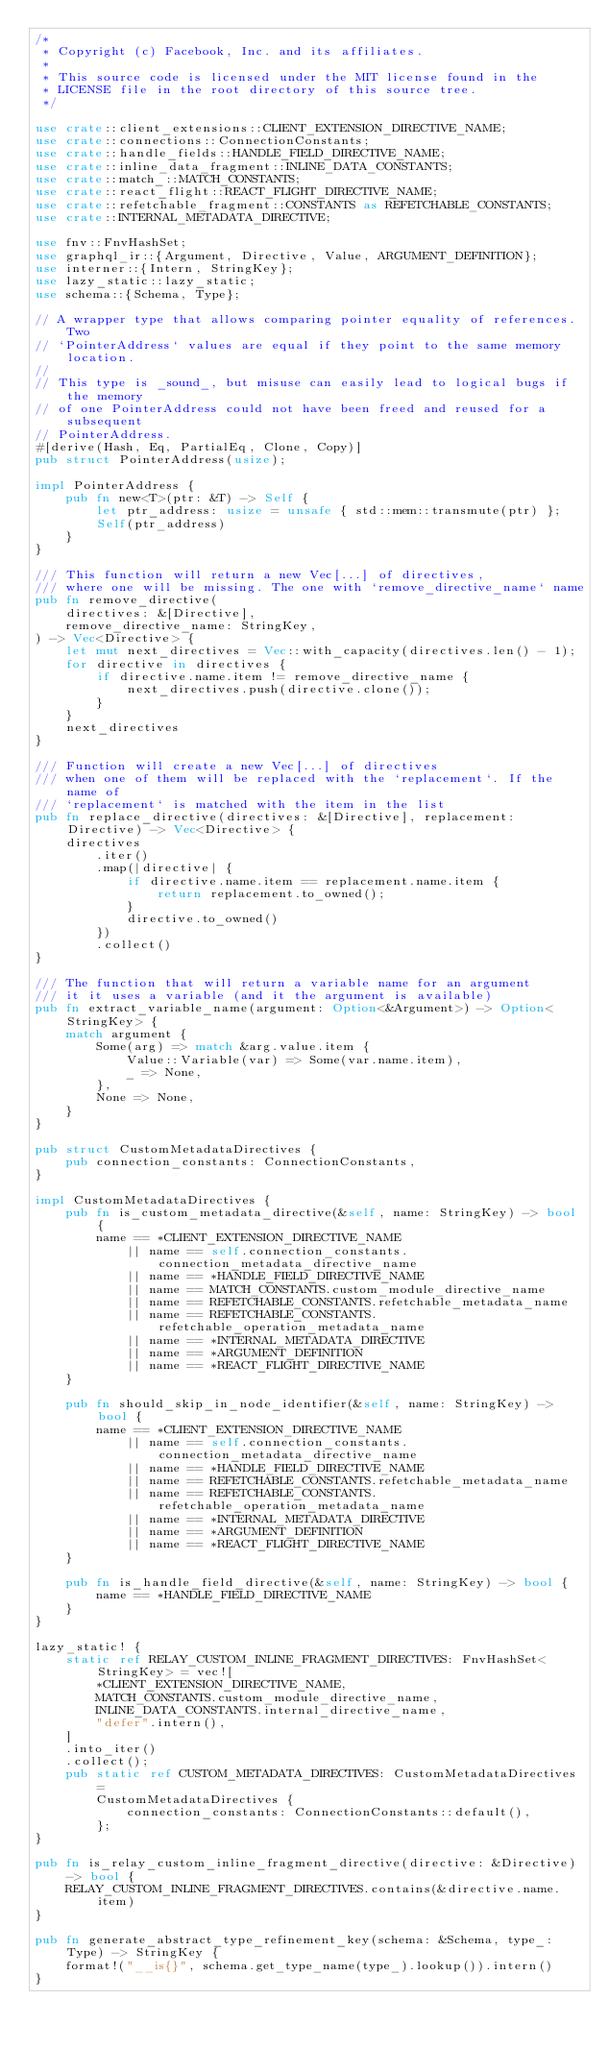<code> <loc_0><loc_0><loc_500><loc_500><_Rust_>/*
 * Copyright (c) Facebook, Inc. and its affiliates.
 *
 * This source code is licensed under the MIT license found in the
 * LICENSE file in the root directory of this source tree.
 */

use crate::client_extensions::CLIENT_EXTENSION_DIRECTIVE_NAME;
use crate::connections::ConnectionConstants;
use crate::handle_fields::HANDLE_FIELD_DIRECTIVE_NAME;
use crate::inline_data_fragment::INLINE_DATA_CONSTANTS;
use crate::match_::MATCH_CONSTANTS;
use crate::react_flight::REACT_FLIGHT_DIRECTIVE_NAME;
use crate::refetchable_fragment::CONSTANTS as REFETCHABLE_CONSTANTS;
use crate::INTERNAL_METADATA_DIRECTIVE;

use fnv::FnvHashSet;
use graphql_ir::{Argument, Directive, Value, ARGUMENT_DEFINITION};
use interner::{Intern, StringKey};
use lazy_static::lazy_static;
use schema::{Schema, Type};

// A wrapper type that allows comparing pointer equality of references. Two
// `PointerAddress` values are equal if they point to the same memory location.
//
// This type is _sound_, but misuse can easily lead to logical bugs if the memory
// of one PointerAddress could not have been freed and reused for a subsequent
// PointerAddress.
#[derive(Hash, Eq, PartialEq, Clone, Copy)]
pub struct PointerAddress(usize);

impl PointerAddress {
    pub fn new<T>(ptr: &T) -> Self {
        let ptr_address: usize = unsafe { std::mem::transmute(ptr) };
        Self(ptr_address)
    }
}

/// This function will return a new Vec[...] of directives,
/// where one will be missing. The one with `remove_directive_name` name
pub fn remove_directive(
    directives: &[Directive],
    remove_directive_name: StringKey,
) -> Vec<Directive> {
    let mut next_directives = Vec::with_capacity(directives.len() - 1);
    for directive in directives {
        if directive.name.item != remove_directive_name {
            next_directives.push(directive.clone());
        }
    }
    next_directives
}

/// Function will create a new Vec[...] of directives
/// when one of them will be replaced with the `replacement`. If the name of
/// `replacement` is matched with the item in the list
pub fn replace_directive(directives: &[Directive], replacement: Directive) -> Vec<Directive> {
    directives
        .iter()
        .map(|directive| {
            if directive.name.item == replacement.name.item {
                return replacement.to_owned();
            }
            directive.to_owned()
        })
        .collect()
}

/// The function that will return a variable name for an argument
/// it it uses a variable (and it the argument is available)
pub fn extract_variable_name(argument: Option<&Argument>) -> Option<StringKey> {
    match argument {
        Some(arg) => match &arg.value.item {
            Value::Variable(var) => Some(var.name.item),
            _ => None,
        },
        None => None,
    }
}

pub struct CustomMetadataDirectives {
    pub connection_constants: ConnectionConstants,
}

impl CustomMetadataDirectives {
    pub fn is_custom_metadata_directive(&self, name: StringKey) -> bool {
        name == *CLIENT_EXTENSION_DIRECTIVE_NAME
            || name == self.connection_constants.connection_metadata_directive_name
            || name == *HANDLE_FIELD_DIRECTIVE_NAME
            || name == MATCH_CONSTANTS.custom_module_directive_name
            || name == REFETCHABLE_CONSTANTS.refetchable_metadata_name
            || name == REFETCHABLE_CONSTANTS.refetchable_operation_metadata_name
            || name == *INTERNAL_METADATA_DIRECTIVE
            || name == *ARGUMENT_DEFINITION
            || name == *REACT_FLIGHT_DIRECTIVE_NAME
    }

    pub fn should_skip_in_node_identifier(&self, name: StringKey) -> bool {
        name == *CLIENT_EXTENSION_DIRECTIVE_NAME
            || name == self.connection_constants.connection_metadata_directive_name
            || name == *HANDLE_FIELD_DIRECTIVE_NAME
            || name == REFETCHABLE_CONSTANTS.refetchable_metadata_name
            || name == REFETCHABLE_CONSTANTS.refetchable_operation_metadata_name
            || name == *INTERNAL_METADATA_DIRECTIVE
            || name == *ARGUMENT_DEFINITION
            || name == *REACT_FLIGHT_DIRECTIVE_NAME
    }

    pub fn is_handle_field_directive(&self, name: StringKey) -> bool {
        name == *HANDLE_FIELD_DIRECTIVE_NAME
    }
}

lazy_static! {
    static ref RELAY_CUSTOM_INLINE_FRAGMENT_DIRECTIVES: FnvHashSet<StringKey> = vec![
        *CLIENT_EXTENSION_DIRECTIVE_NAME,
        MATCH_CONSTANTS.custom_module_directive_name,
        INLINE_DATA_CONSTANTS.internal_directive_name,
        "defer".intern(),
    ]
    .into_iter()
    .collect();
    pub static ref CUSTOM_METADATA_DIRECTIVES: CustomMetadataDirectives =
        CustomMetadataDirectives {
            connection_constants: ConnectionConstants::default(),
        };
}

pub fn is_relay_custom_inline_fragment_directive(directive: &Directive) -> bool {
    RELAY_CUSTOM_INLINE_FRAGMENT_DIRECTIVES.contains(&directive.name.item)
}

pub fn generate_abstract_type_refinement_key(schema: &Schema, type_: Type) -> StringKey {
    format!("__is{}", schema.get_type_name(type_).lookup()).intern()
}
</code> 